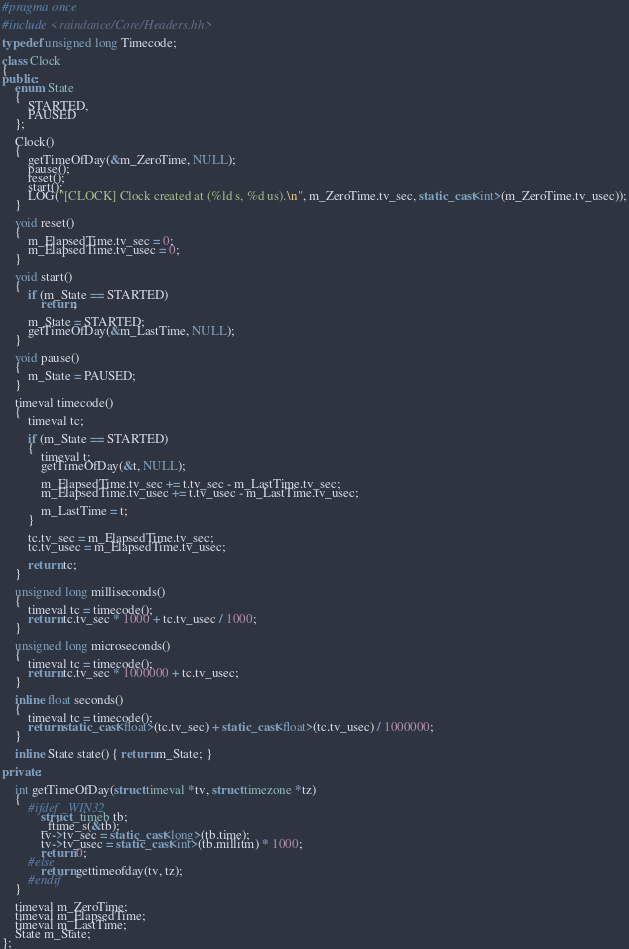<code> <loc_0><loc_0><loc_500><loc_500><_C++_>#pragma once

#include <raindance/Core/Headers.hh>

typedef unsigned long Timecode;

class Clock
{
public:
    enum State
    {
        STARTED,
        PAUSED
    };

	Clock()
	{
		getTimeOfDay(&m_ZeroTime, NULL);
        pause();
        reset();
		start();
        LOG("[CLOCK] Clock created at (%ld s, %d us).\n", m_ZeroTime.tv_sec, static_cast<int>(m_ZeroTime.tv_usec));
	}

	void reset()
	{
		m_ElapsedTime.tv_sec = 0;
		m_ElapsedTime.tv_usec = 0;
	}

	void start()
	{
	    if (m_State == STARTED)
	        return;

	    m_State = STARTED;
		getTimeOfDay(&m_LastTime, NULL);
	}

	void pause()
	{
	    m_State = PAUSED;
	}

    timeval timecode()
    {
        timeval tc;

        if (m_State == STARTED)
        {
            timeval t;
			getTimeOfDay(&t, NULL);

            m_ElapsedTime.tv_sec += t.tv_sec - m_LastTime.tv_sec;
            m_ElapsedTime.tv_usec += t.tv_usec - m_LastTime.tv_usec;

            m_LastTime = t;
        }

        tc.tv_sec = m_ElapsedTime.tv_sec;
        tc.tv_usec = m_ElapsedTime.tv_usec;

        return tc;
    }

    unsigned long milliseconds()
    {
        timeval tc = timecode();
		return tc.tv_sec * 1000 + tc.tv_usec / 1000;
	}

	unsigned long microseconds()
	{
	    timeval tc = timecode();
		return tc.tv_sec * 1000000 + tc.tv_usec;
	}

	inline float seconds()
	{
	    timeval tc = timecode();
	    return static_cast<float>(tc.tv_sec) + static_cast<float>(tc.tv_usec) / 1000000;
	}

	inline State state() { return m_State; }

private:

	int getTimeOfDay(struct timeval *tv, struct timezone *tz)
	{
		#ifdef _WIN32
			struct _timeb tb;
			_ftime_s(&tb);
			tv->tv_sec = static_cast<long>(tb.time);
			tv->tv_usec = static_cast<int>(tb.millitm) * 1000;
			return 0;
		#else
			return gettimeofday(tv, tz);
		#endif
	}
	
	timeval m_ZeroTime;
	timeval m_ElapsedTime;
    timeval m_LastTime;
	State m_State;
};

</code> 